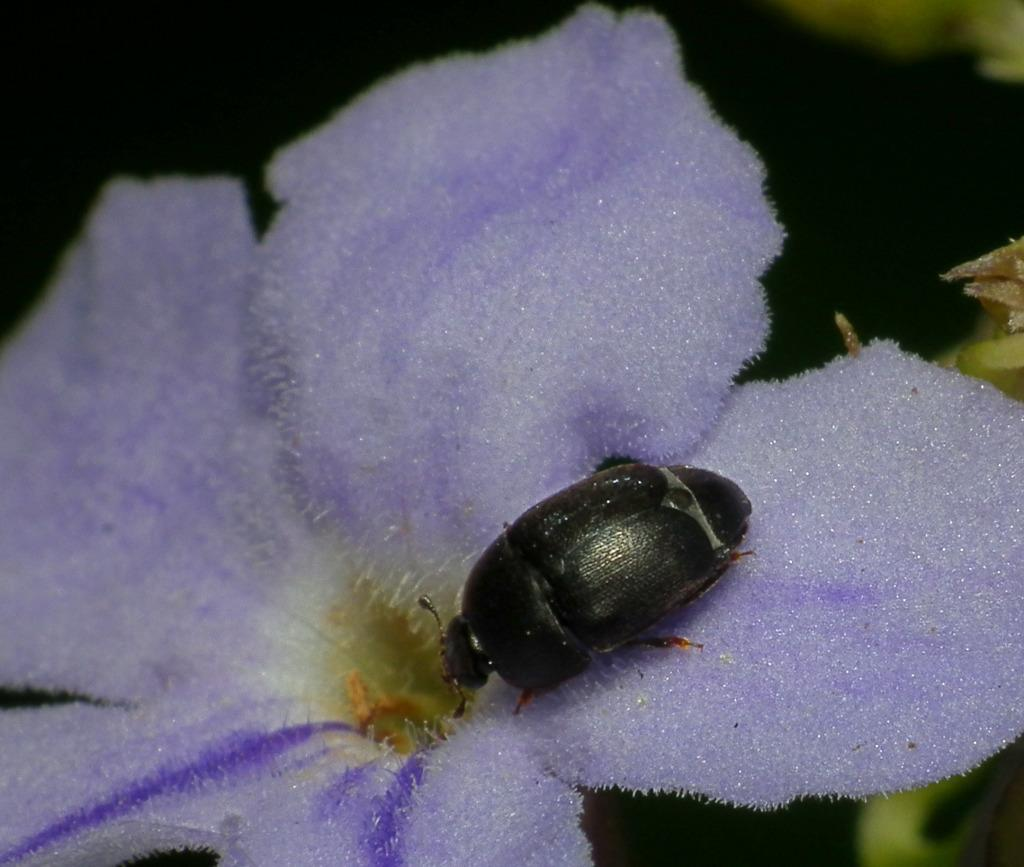What type of creature is in the image? There is an insect in the image. What is the insect sitting on? The insect is on a purple flower. What color is the background in the image? The background in the image is dark. What type of vegetation is visible in the image? There are green leaves visible in the image. Where is the hat located in the image? There is no hat present in the image. What type of bag can be seen hanging from the tree in the image? There is no bag or tree present in the image. 